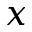<formula> <loc_0><loc_0><loc_500><loc_500>x</formula> 